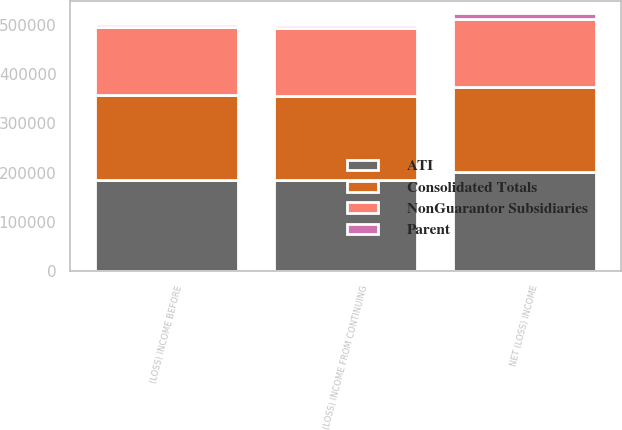Convert chart. <chart><loc_0><loc_0><loc_500><loc_500><stacked_bar_chart><ecel><fcel>(LOSS) INCOME FROM CONTINUING<fcel>(LOSS) INCOME BEFORE<fcel>NET (LOSS) INCOME<nl><fcel>Consolidated Totals<fcel>170324<fcel>171590<fcel>171590<nl><fcel>ATI<fcel>184762<fcel>185431<fcel>201361<nl><fcel>NonGuarantor Subsidiaries<fcel>138041<fcel>138041<fcel>138041<nl><fcel>Parent<fcel>7370<fcel>7370<fcel>12225<nl></chart> 